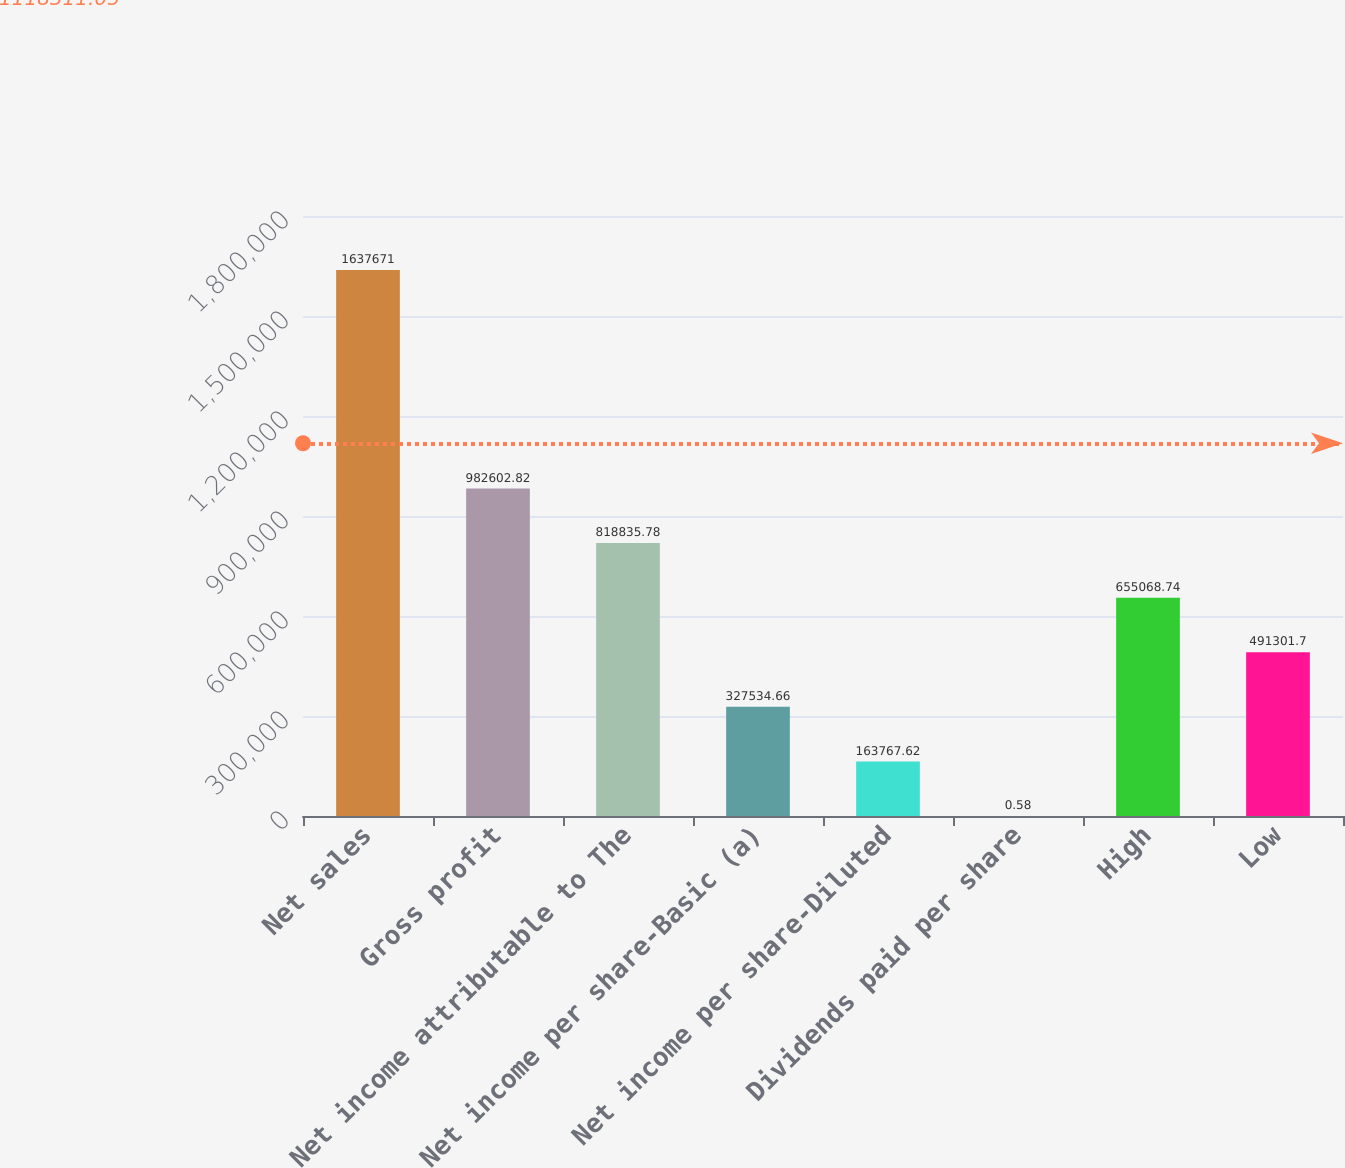<chart> <loc_0><loc_0><loc_500><loc_500><bar_chart><fcel>Net sales<fcel>Gross profit<fcel>Net income attributable to The<fcel>Net income per share-Basic (a)<fcel>Net income per share-Diluted<fcel>Dividends paid per share<fcel>High<fcel>Low<nl><fcel>1.63767e+06<fcel>982603<fcel>818836<fcel>327535<fcel>163768<fcel>0.58<fcel>655069<fcel>491302<nl></chart> 